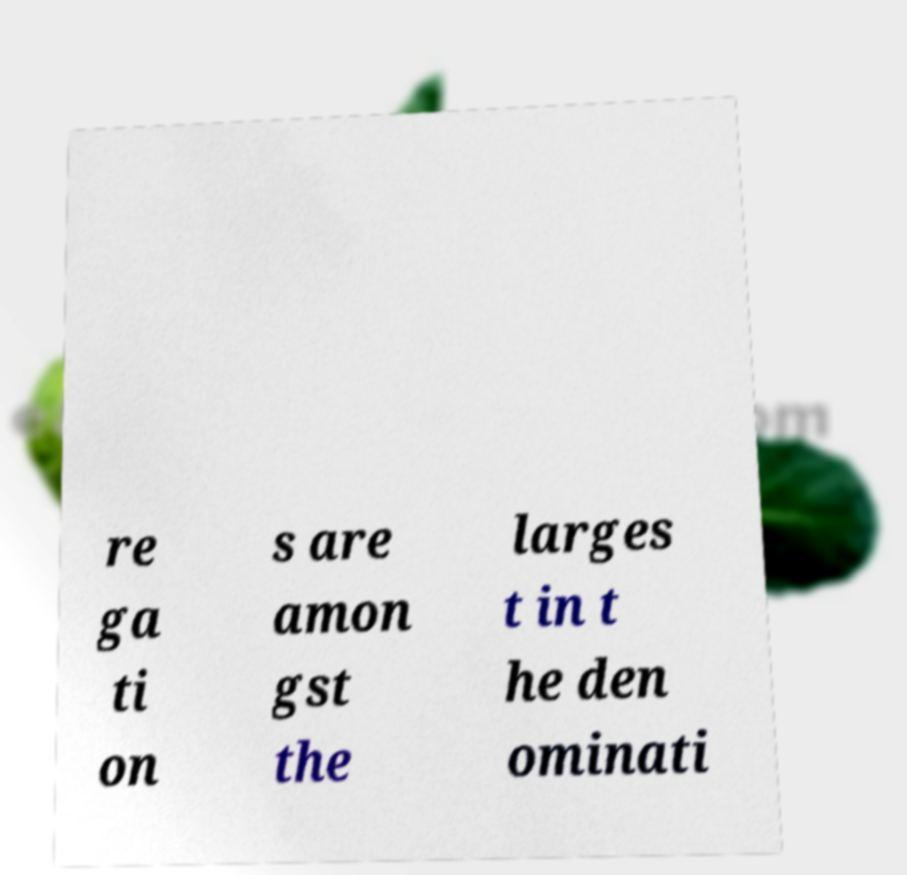Can you read and provide the text displayed in the image?This photo seems to have some interesting text. Can you extract and type it out for me? re ga ti on s are amon gst the larges t in t he den ominati 